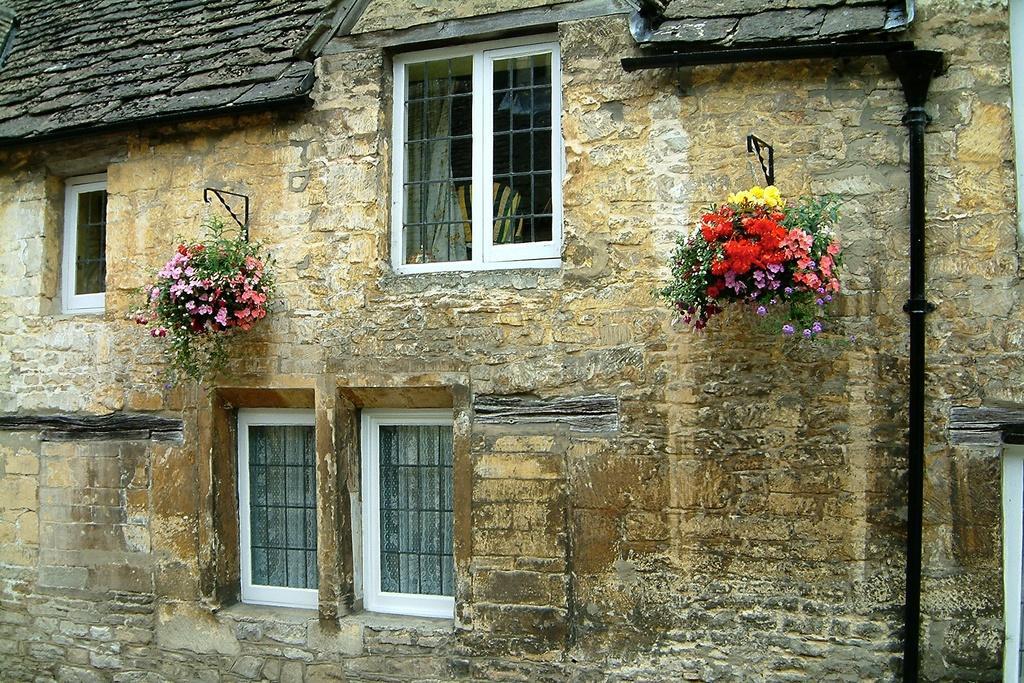Could you give a brief overview of what you see in this image? In this image there is a building and we can see windows. There are house plants and we can see flowers. On the right there is a rod. 